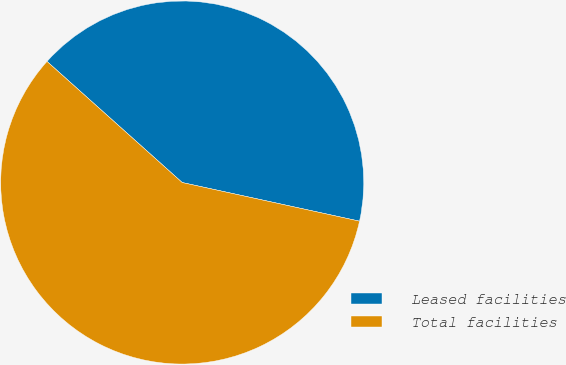Convert chart. <chart><loc_0><loc_0><loc_500><loc_500><pie_chart><fcel>Leased facilities<fcel>Total facilities<nl><fcel>41.79%<fcel>58.21%<nl></chart> 